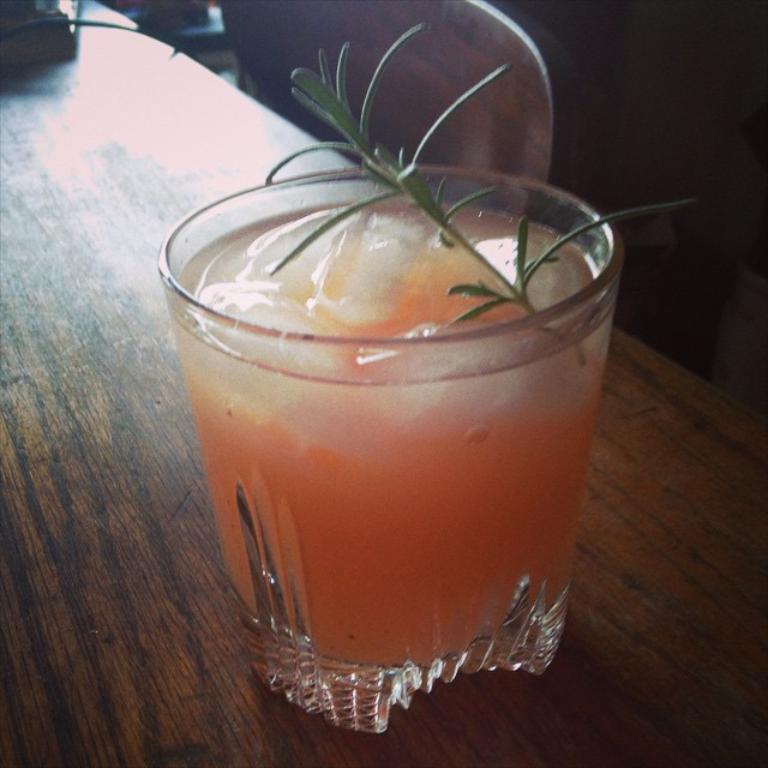Could you give a brief overview of what you see in this image? In this picture we can see a table,on this table we can see a glass with drink in it. 